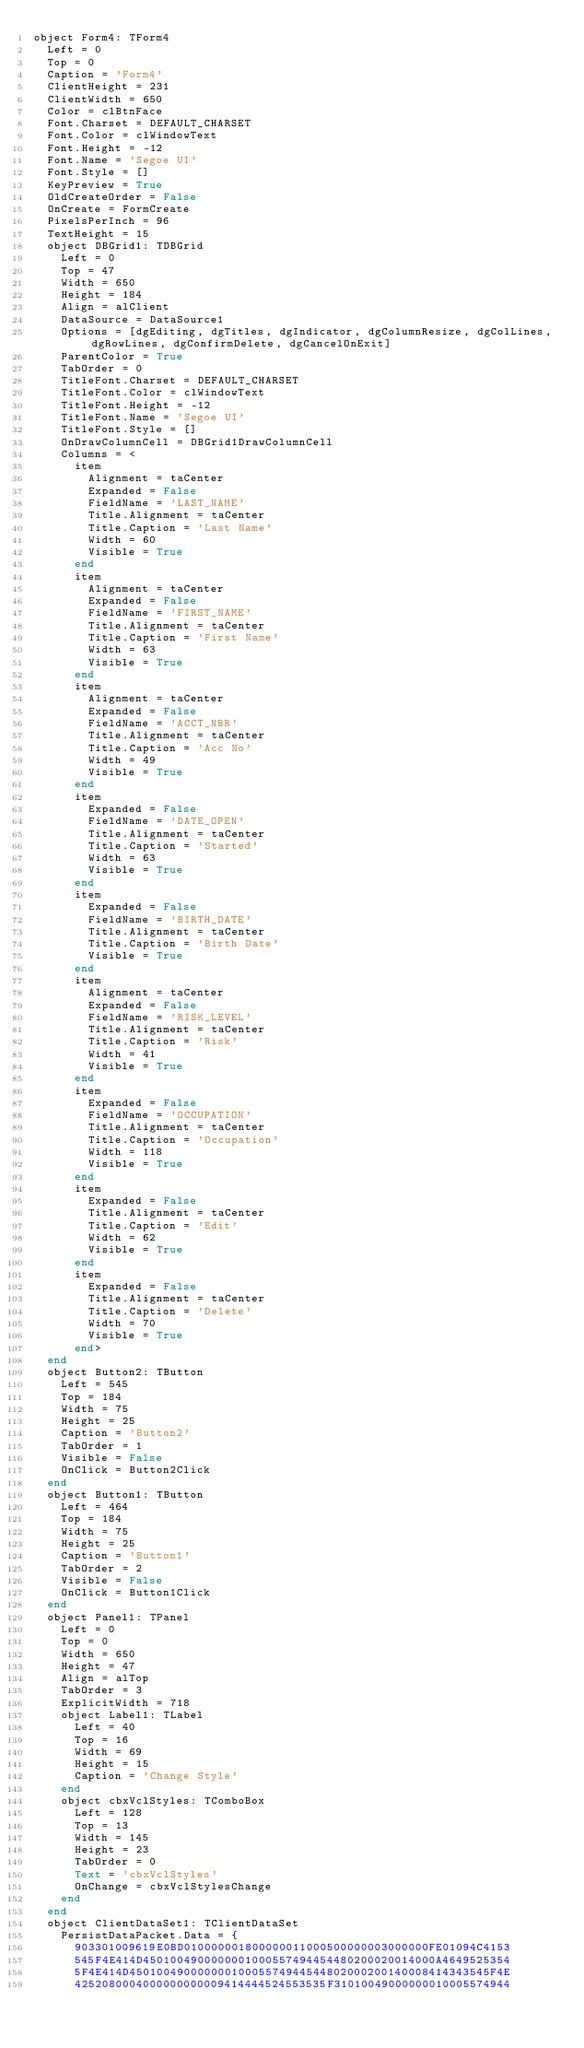<code> <loc_0><loc_0><loc_500><loc_500><_Pascal_>object Form4: TForm4
  Left = 0
  Top = 0
  Caption = 'Form4'
  ClientHeight = 231
  ClientWidth = 650
  Color = clBtnFace
  Font.Charset = DEFAULT_CHARSET
  Font.Color = clWindowText
  Font.Height = -12
  Font.Name = 'Segoe UI'
  Font.Style = []
  KeyPreview = True
  OldCreateOrder = False
  OnCreate = FormCreate
  PixelsPerInch = 96
  TextHeight = 15
  object DBGrid1: TDBGrid
    Left = 0
    Top = 47
    Width = 650
    Height = 184
    Align = alClient
    DataSource = DataSource1
    Options = [dgEditing, dgTitles, dgIndicator, dgColumnResize, dgColLines, dgRowLines, dgConfirmDelete, dgCancelOnExit]
    ParentColor = True
    TabOrder = 0
    TitleFont.Charset = DEFAULT_CHARSET
    TitleFont.Color = clWindowText
    TitleFont.Height = -12
    TitleFont.Name = 'Segoe UI'
    TitleFont.Style = []
    OnDrawColumnCell = DBGrid1DrawColumnCell
    Columns = <
      item
        Alignment = taCenter
        Expanded = False
        FieldName = 'LAST_NAME'
        Title.Alignment = taCenter
        Title.Caption = 'Last Name'
        Width = 60
        Visible = True
      end
      item
        Alignment = taCenter
        Expanded = False
        FieldName = 'FIRST_NAME'
        Title.Alignment = taCenter
        Title.Caption = 'First Name'
        Width = 63
        Visible = True
      end
      item
        Alignment = taCenter
        Expanded = False
        FieldName = 'ACCT_NBR'
        Title.Alignment = taCenter
        Title.Caption = 'Acc No'
        Width = 49
        Visible = True
      end
      item
        Expanded = False
        FieldName = 'DATE_OPEN'
        Title.Alignment = taCenter
        Title.Caption = 'Started'
        Width = 63
        Visible = True
      end
      item
        Expanded = False
        FieldName = 'BIRTH_DATE'
        Title.Alignment = taCenter
        Title.Caption = 'Birth Date'
        Visible = True
      end
      item
        Alignment = taCenter
        Expanded = False
        FieldName = 'RISK_LEVEL'
        Title.Alignment = taCenter
        Title.Caption = 'Risk'
        Width = 41
        Visible = True
      end
      item
        Expanded = False
        FieldName = 'OCCUPATION'
        Title.Alignment = taCenter
        Title.Caption = 'Occupation'
        Width = 118
        Visible = True
      end
      item
        Expanded = False
        Title.Alignment = taCenter
        Title.Caption = 'Edit'
        Width = 62
        Visible = True
      end
      item
        Expanded = False
        Title.Alignment = taCenter
        Title.Caption = 'Delete'
        Width = 70
        Visible = True
      end>
  end
  object Button2: TButton
    Left = 545
    Top = 184
    Width = 75
    Height = 25
    Caption = 'Button2'
    TabOrder = 1
    Visible = False
    OnClick = Button2Click
  end
  object Button1: TButton
    Left = 464
    Top = 184
    Width = 75
    Height = 25
    Caption = 'Button1'
    TabOrder = 2
    Visible = False
    OnClick = Button1Click
  end
  object Panel1: TPanel
    Left = 0
    Top = 0
    Width = 650
    Height = 47
    Align = alTop
    TabOrder = 3
    ExplicitWidth = 718
    object Label1: TLabel
      Left = 40
      Top = 16
      Width = 69
      Height = 15
      Caption = 'Change Style'
    end
    object cbxVclStyles: TComboBox
      Left = 128
      Top = 13
      Width = 145
      Height = 23
      TabOrder = 0
      Text = 'cbxVclStyles'
      OnChange = cbxVclStylesChange
    end
  end
  object ClientDataSet1: TClientDataSet
    PersistDataPacket.Data = {
      903301009619E0BD010000001800000011000500000003000000FE01094C4153
      545F4E414D4501004900000001000557494454480200020014000A4649525354
      5F4E414D45010049000000010005574944544802000200140008414343545F4E
      4252080004000000000009414444524553535F31010049000000010005574944</code> 